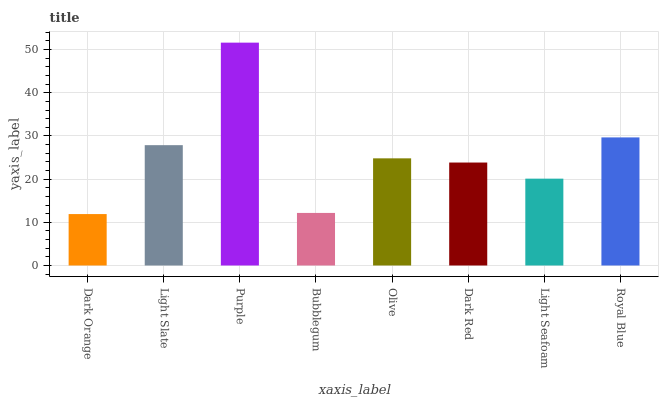Is Light Slate the minimum?
Answer yes or no. No. Is Light Slate the maximum?
Answer yes or no. No. Is Light Slate greater than Dark Orange?
Answer yes or no. Yes. Is Dark Orange less than Light Slate?
Answer yes or no. Yes. Is Dark Orange greater than Light Slate?
Answer yes or no. No. Is Light Slate less than Dark Orange?
Answer yes or no. No. Is Olive the high median?
Answer yes or no. Yes. Is Dark Red the low median?
Answer yes or no. Yes. Is Light Slate the high median?
Answer yes or no. No. Is Purple the low median?
Answer yes or no. No. 